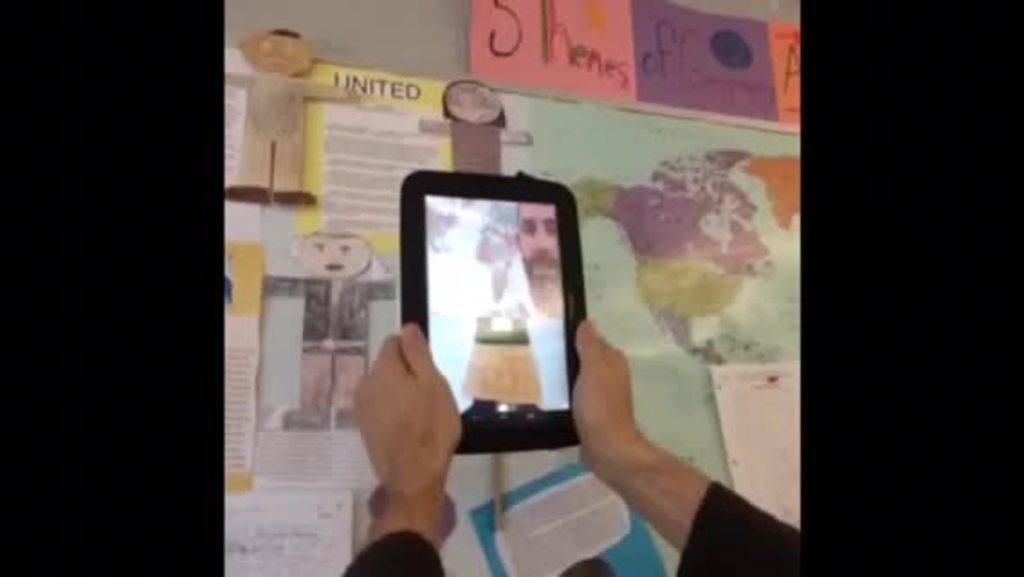Describe this image in one or two sentences. In this picture there is a person holding a smartphone with both of his hands. In the backdrop there are some paintings and a map fixed on the notice board. 